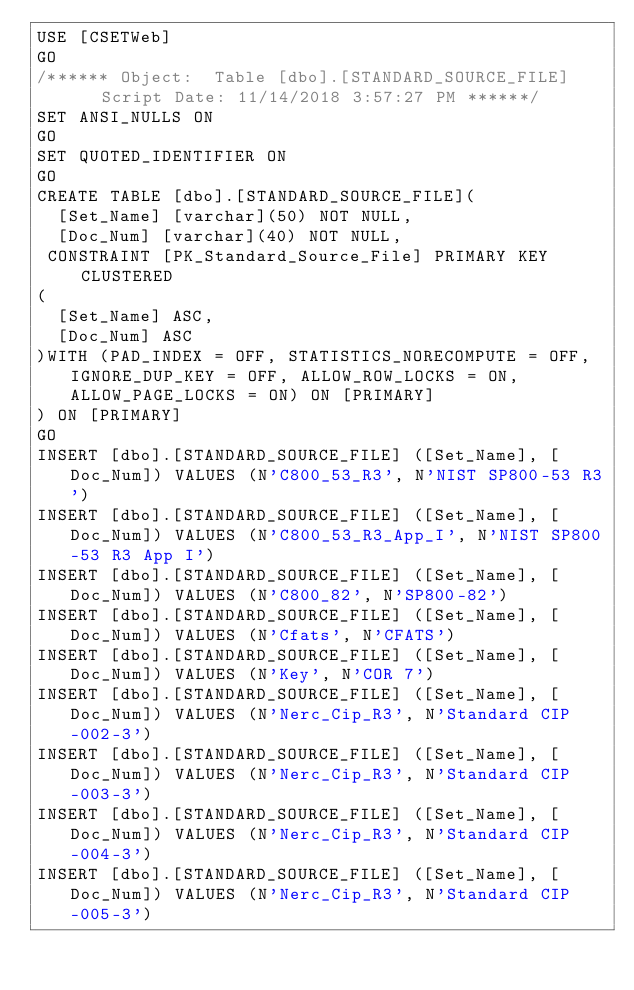Convert code to text. <code><loc_0><loc_0><loc_500><loc_500><_SQL_>USE [CSETWeb]
GO
/****** Object:  Table [dbo].[STANDARD_SOURCE_FILE]    Script Date: 11/14/2018 3:57:27 PM ******/
SET ANSI_NULLS ON
GO
SET QUOTED_IDENTIFIER ON
GO
CREATE TABLE [dbo].[STANDARD_SOURCE_FILE](
	[Set_Name] [varchar](50) NOT NULL,
	[Doc_Num] [varchar](40) NOT NULL,
 CONSTRAINT [PK_Standard_Source_File] PRIMARY KEY CLUSTERED 
(
	[Set_Name] ASC,
	[Doc_Num] ASC
)WITH (PAD_INDEX = OFF, STATISTICS_NORECOMPUTE = OFF, IGNORE_DUP_KEY = OFF, ALLOW_ROW_LOCKS = ON, ALLOW_PAGE_LOCKS = ON) ON [PRIMARY]
) ON [PRIMARY]
GO
INSERT [dbo].[STANDARD_SOURCE_FILE] ([Set_Name], [Doc_Num]) VALUES (N'C800_53_R3', N'NIST SP800-53 R3')
INSERT [dbo].[STANDARD_SOURCE_FILE] ([Set_Name], [Doc_Num]) VALUES (N'C800_53_R3_App_I', N'NIST SP800-53 R3 App I')
INSERT [dbo].[STANDARD_SOURCE_FILE] ([Set_Name], [Doc_Num]) VALUES (N'C800_82', N'SP800-82')
INSERT [dbo].[STANDARD_SOURCE_FILE] ([Set_Name], [Doc_Num]) VALUES (N'Cfats', N'CFATS')
INSERT [dbo].[STANDARD_SOURCE_FILE] ([Set_Name], [Doc_Num]) VALUES (N'Key', N'COR 7')
INSERT [dbo].[STANDARD_SOURCE_FILE] ([Set_Name], [Doc_Num]) VALUES (N'Nerc_Cip_R3', N'Standard CIP-002-3')
INSERT [dbo].[STANDARD_SOURCE_FILE] ([Set_Name], [Doc_Num]) VALUES (N'Nerc_Cip_R3', N'Standard CIP-003-3')
INSERT [dbo].[STANDARD_SOURCE_FILE] ([Set_Name], [Doc_Num]) VALUES (N'Nerc_Cip_R3', N'Standard CIP-004-3')
INSERT [dbo].[STANDARD_SOURCE_FILE] ([Set_Name], [Doc_Num]) VALUES (N'Nerc_Cip_R3', N'Standard CIP-005-3')</code> 